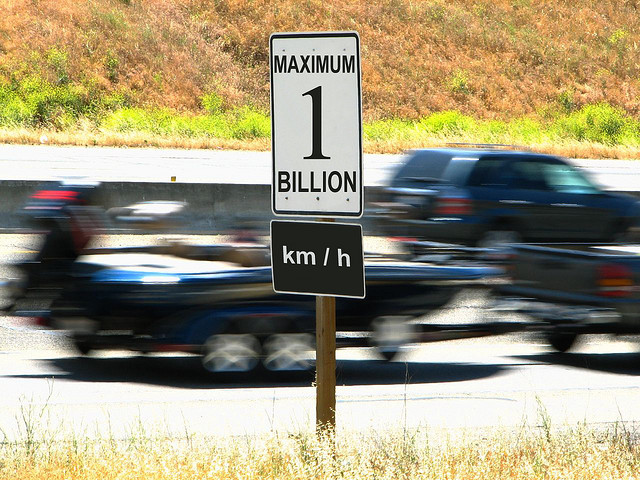What does the motion blur in the background indicate about the setting? The motion blur of the vehicles in the background shows that the photo was taken with a slower shutter speed, capturing the movement of the cars and providing a sense of speed on the roadway. It contrasts with the static and clear road sign, emphasizing the unrealistic speed limit posted. 